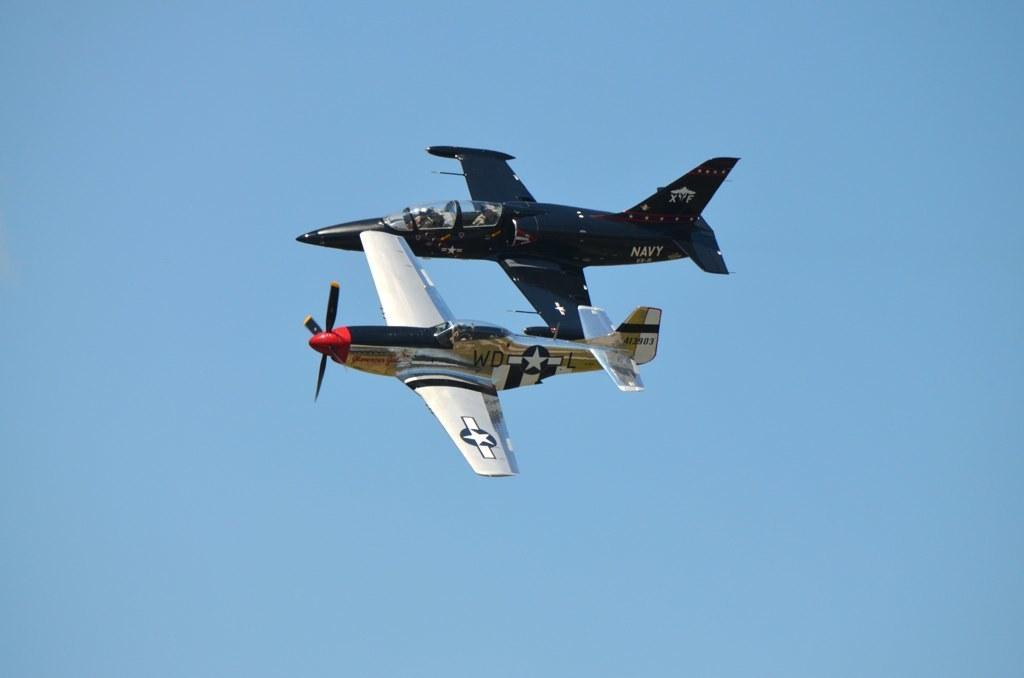In one or two sentences, can you explain what this image depicts? There are two airplanes present in the middle of this image and the sky is in the background. 